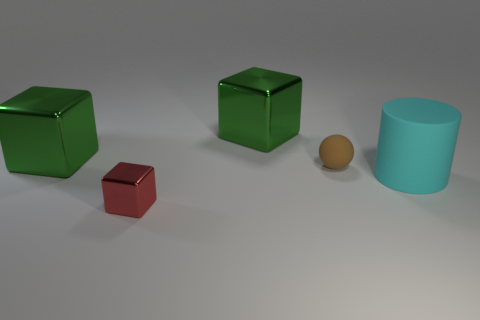Are there any purple cubes made of the same material as the ball?
Provide a short and direct response. No. The thing that is in front of the brown object and on the left side of the tiny matte sphere has what shape?
Make the answer very short. Cube. What number of other things are the same shape as the tiny brown object?
Your response must be concise. 0. The red metallic object has what size?
Your answer should be compact. Small. What number of things are tiny brown balls or small things?
Provide a short and direct response. 2. There is a shiny thing that is in front of the big rubber cylinder; how big is it?
Make the answer very short. Small. The object that is in front of the tiny rubber thing and left of the large cylinder is what color?
Offer a terse response. Red. Does the big block that is to the left of the tiny red thing have the same material as the brown thing?
Your response must be concise. No. There is a matte cylinder; is its color the same as the shiny block in front of the cyan matte cylinder?
Make the answer very short. No. Are there any small blocks left of the rubber cylinder?
Keep it short and to the point. Yes. 